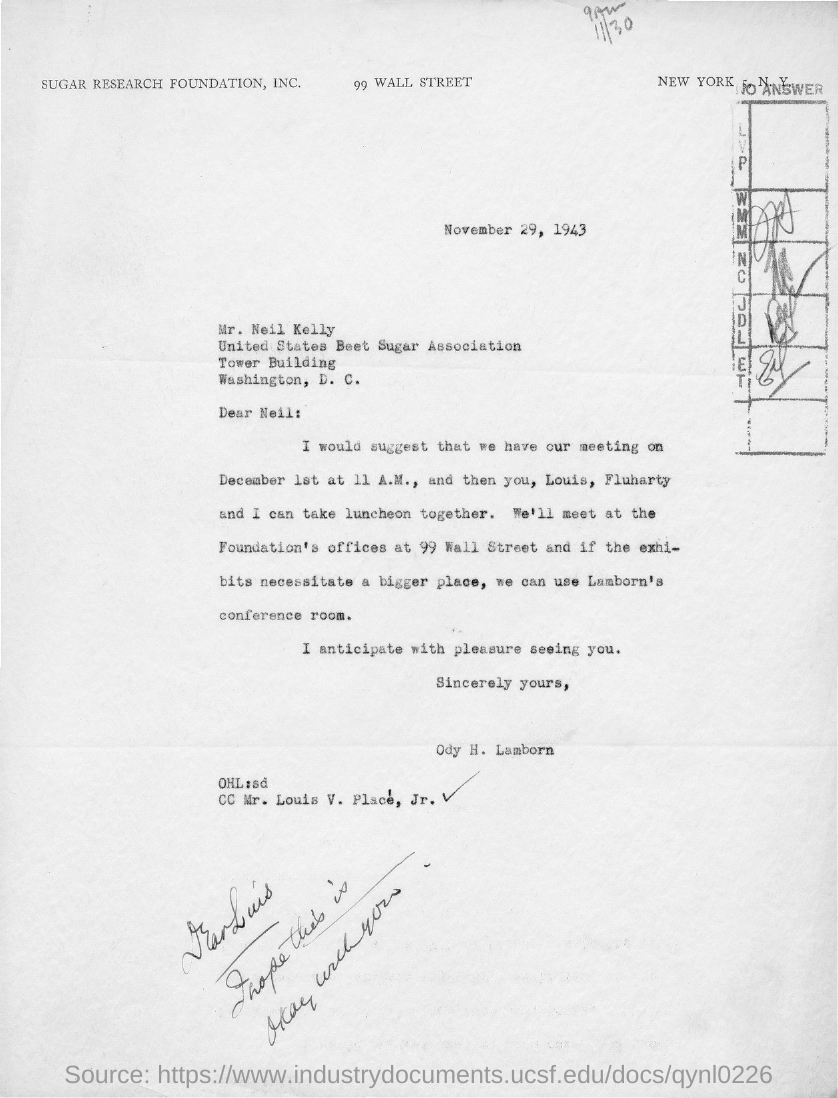Who is the sender of this letter?
Offer a terse response. Ody H. Lamborn. Who is marked in the cc of this letter?
Your answer should be compact. Mr. Louis V. Place', Jr. Who is the addressee of this letter?
Ensure brevity in your answer.  Neil:. What is the issued date of this letter?
Offer a very short reply. November 29, 1943. 